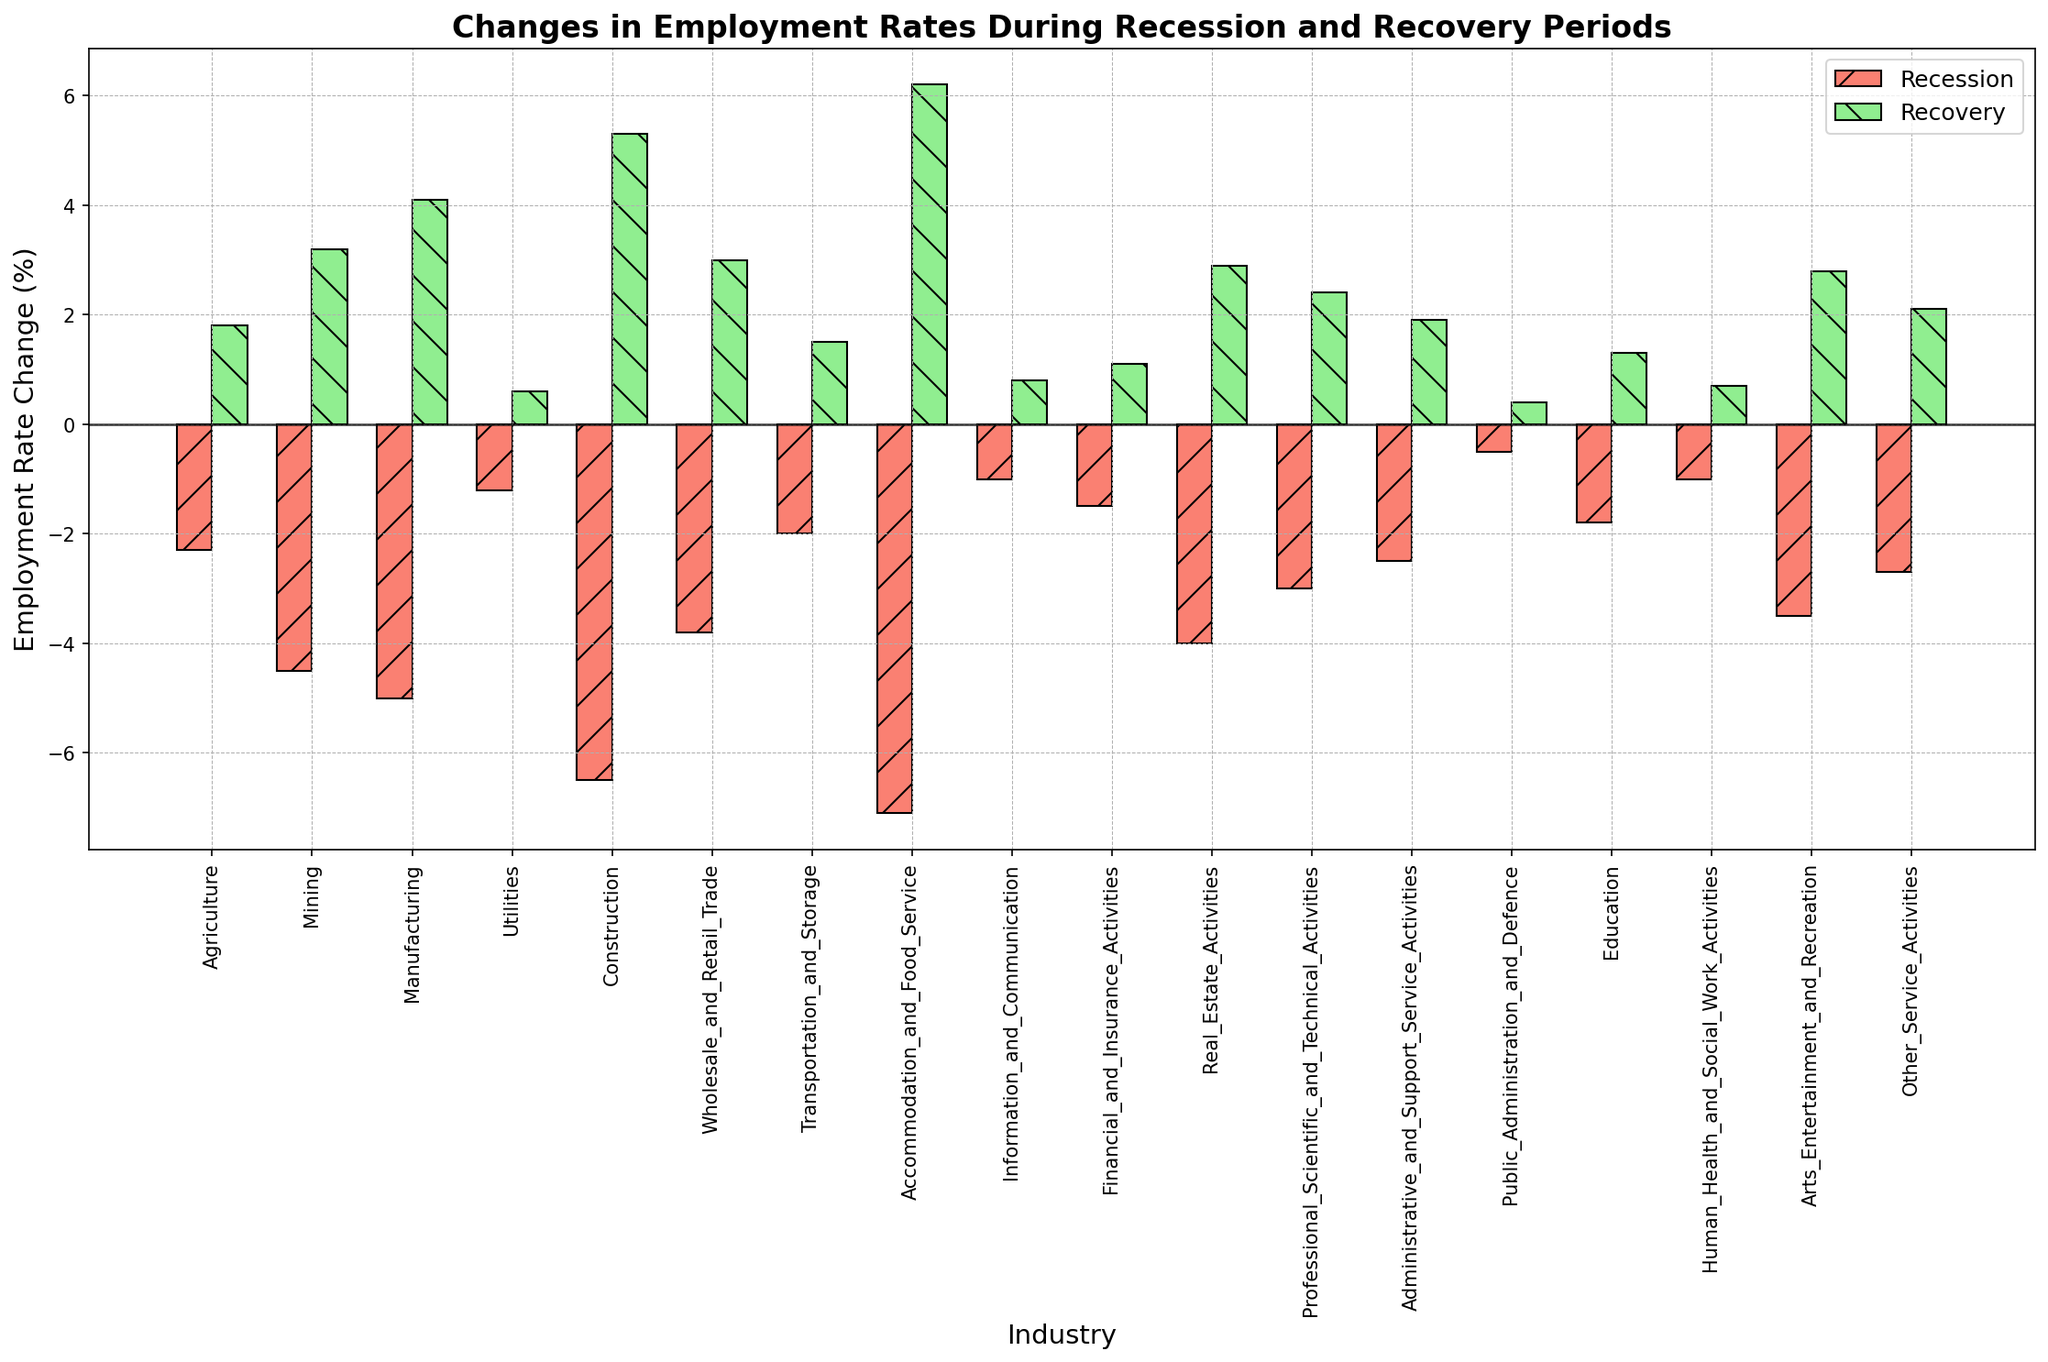Which industry has the largest increase in employment rate during the recovery period? To determine the largest increase in the employment rate during the recovery period, look at the height of the green bars in the chart. The tallest green bar indicates the industry with the largest increase.
Answer: Accommodation and Food Service Which industry experienced the smallest decrease in employment rate during the recession period? To find the smallest decrease, look at the smallest red bar (most positive) during the recession period; it represents the industry with the least negative value.
Answer: Public Administration and Defence What is the difference in employment rate change between the Mining and Manufacturing industries during the recovery period? Subtract the recovery rate of Mining from that of Manufacturing. Recovery rate for Manufacturing (4.1%) - Recovery rate for Mining (3.2%) = 0.9%
Answer: 0.9% Which industry has the most similar employment rate changes during both the recession and recovery periods? Compare the height of the red and green bars for each industry. The industry with similar heights in both periods has the most similar changes.
Answer: Information and Communication What is the average employment rate change during the recession for the Financial and Insurance Activities and Real Estate Activities industries? To find the average, sum the recession rate changes for both industries and divide by 2. (-1.5 + -4.0) / 2 = -2.75
Answer: -2.75 During the recovery period, is the employment rate change in the Wholesale and Retail Trade industry greater than in the Professional, Scientific, and Technical Activities industry? Compare the height of the green bars of these two industries. The one with a taller green bar has a greater employment rate change. Wholesale and Retail Trade = 3.0; Professional, Scientific, and Technical Activities = 2.4.
Answer: Yes Which industry showed the largest difference in employment rate change between the recession and recovery periods? Check all industries' red and green bars. The one with the largest disparity (difference in lengths) has the largest change.
Answer: Accommodation and Food Service How much more did the Construction industry’s employment rate change during recovery compared to the recession? Subtract the recession rate of Construction from its recovery rate. 5.3% - (-6.5%) = 5.3% + 6.5% = 11.8%
Answer: 11.8% Which industry had an employment rate change of more than 5% during both the recession and recovery periods? Look for industries with both red and green bars exceeding the 5% mark in either direction. Only Accommodation and Food Service satisfies this condition.
Answer: Accommodation and Food Service What is the total employment rate change for the Transportation and Storage industry over both periods? Sum the recession rate change and the recovery rate change for Transportation and Storage. -2.0% + 1.5% = -0.5%
Answer: -0.5% 